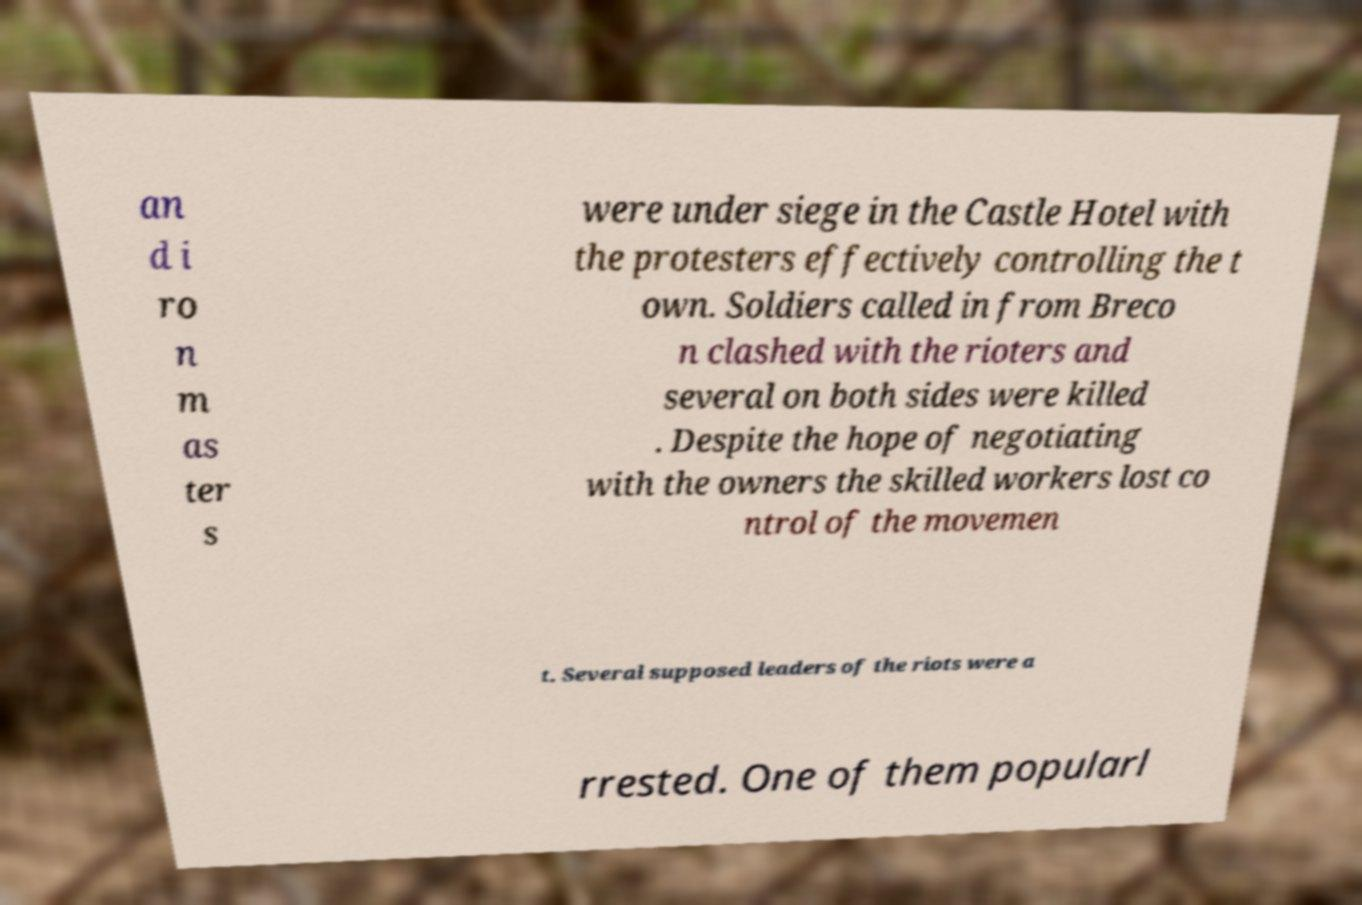Please read and relay the text visible in this image. What does it say? an d i ro n m as ter s were under siege in the Castle Hotel with the protesters effectively controlling the t own. Soldiers called in from Breco n clashed with the rioters and several on both sides were killed . Despite the hope of negotiating with the owners the skilled workers lost co ntrol of the movemen t. Several supposed leaders of the riots were a rrested. One of them popularl 